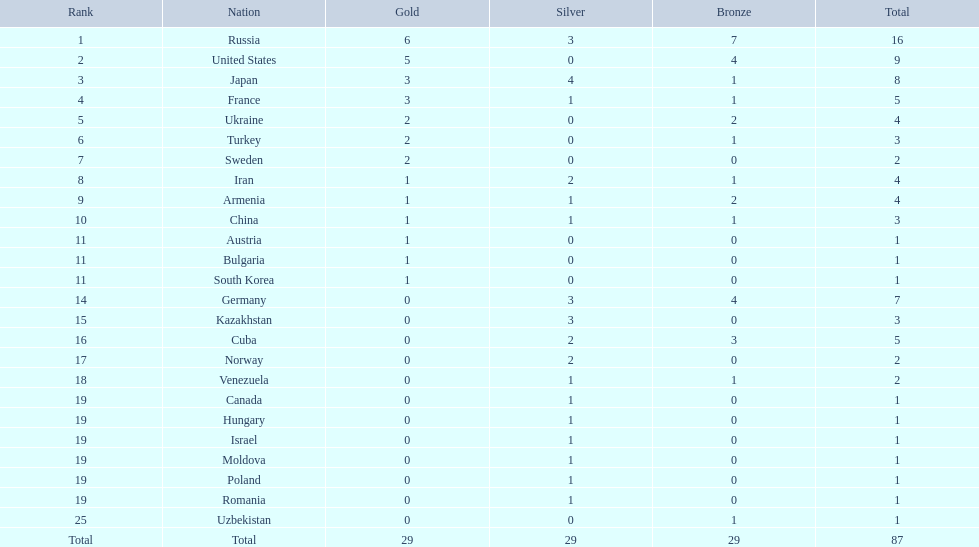Which nations participated in the 1995 global wrestling championships? Russia, United States, Japan, France, Ukraine, Turkey, Sweden, Iran, Armenia, China, Austria, Bulgaria, South Korea, Germany, Kazakhstan, Cuba, Norway, Venezuela, Canada, Hungary, Israel, Moldova, Poland, Romania, Uzbekistan. What nation secured just one medal? Austria, Bulgaria, South Korea, Canada, Hungary, Israel, Moldova, Poland, Romania, Uzbekistan. Which amongst these earned a bronze medal? Uzbekistan. 